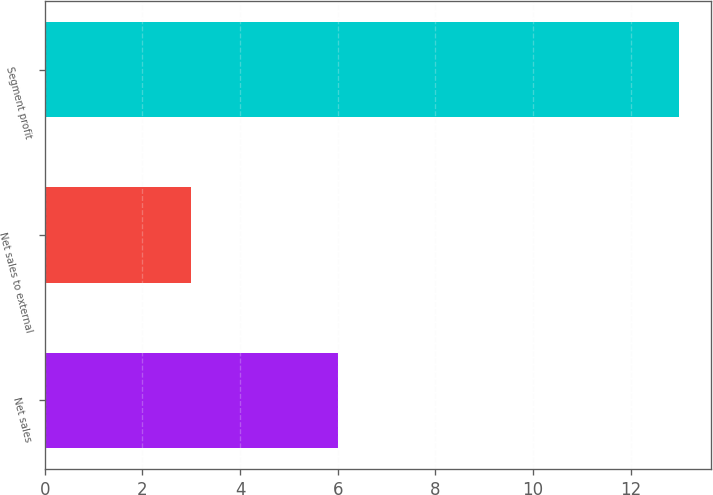Convert chart to OTSL. <chart><loc_0><loc_0><loc_500><loc_500><bar_chart><fcel>Net sales<fcel>Net sales to external<fcel>Segment profit<nl><fcel>6<fcel>3<fcel>13<nl></chart> 